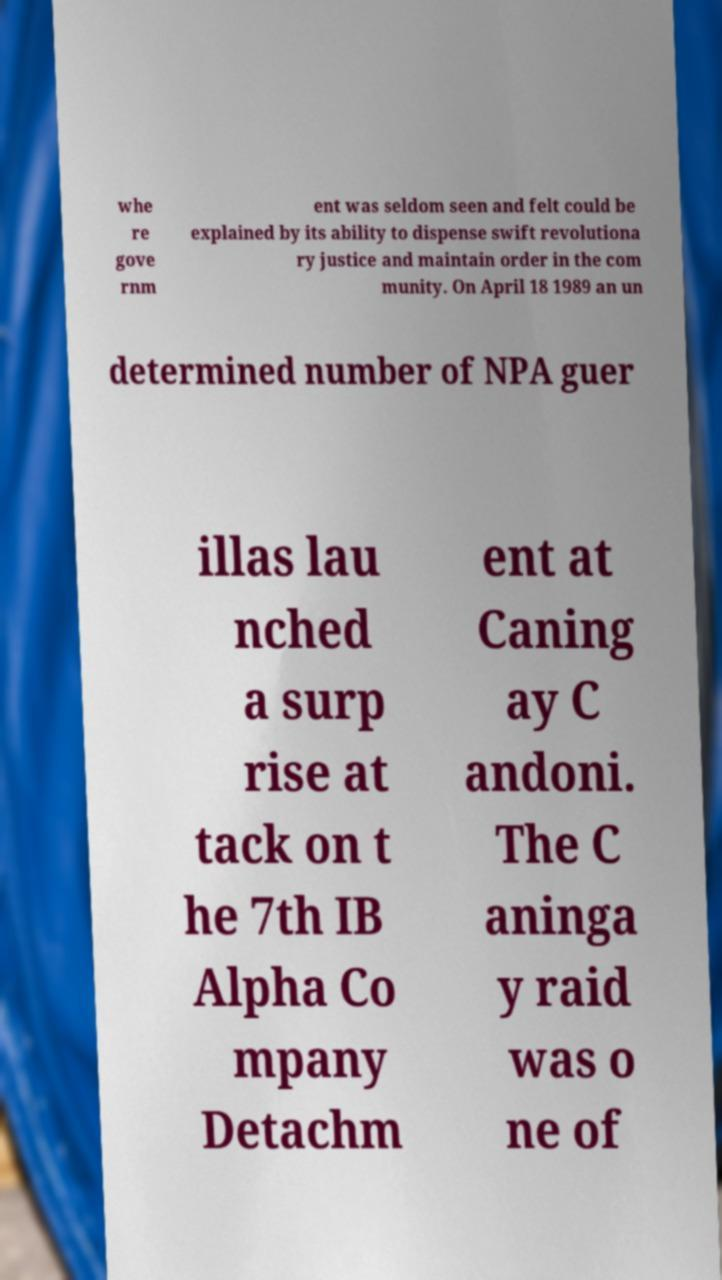Please identify and transcribe the text found in this image. whe re gove rnm ent was seldom seen and felt could be explained by its ability to dispense swift revolutiona ry justice and maintain order in the com munity. On April 18 1989 an un determined number of NPA guer illas lau nched a surp rise at tack on t he 7th IB Alpha Co mpany Detachm ent at Caning ay C andoni. The C aninga y raid was o ne of 